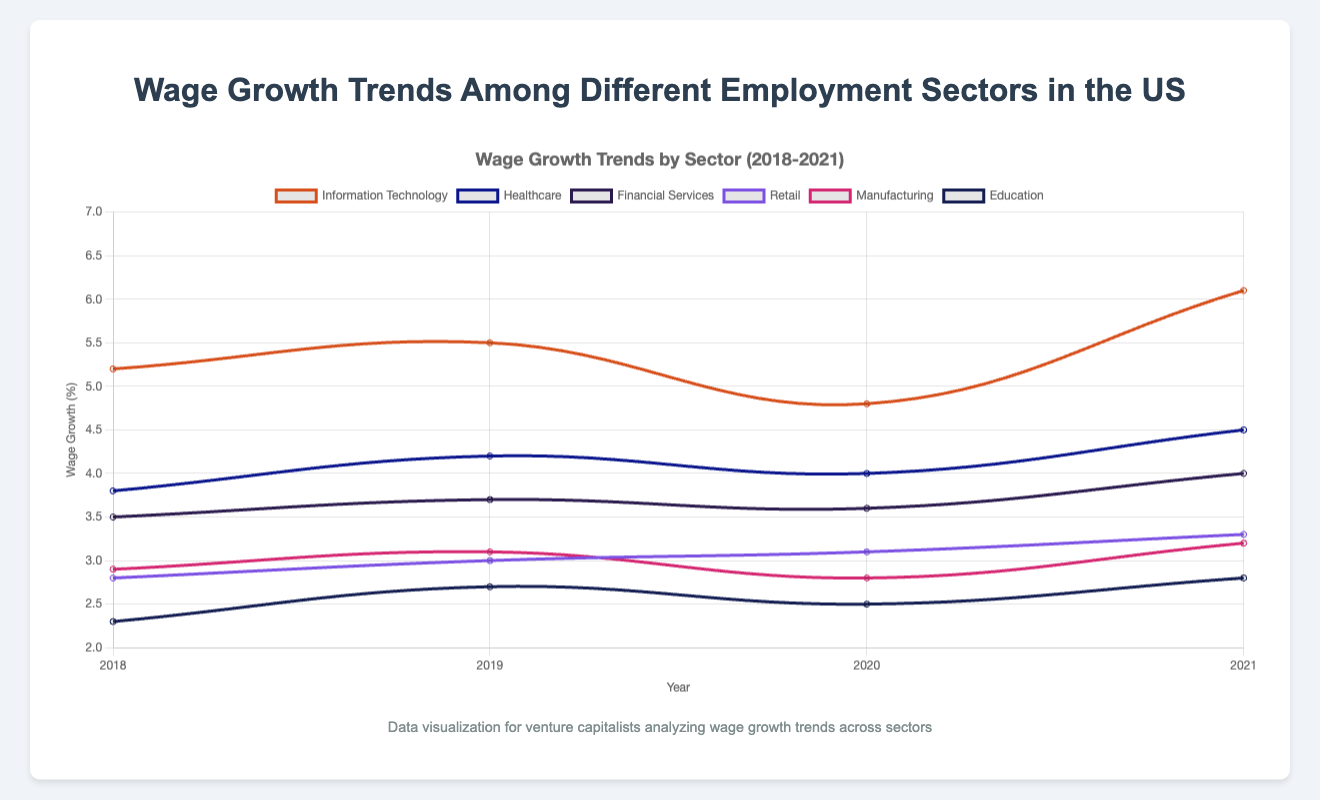Which sector had the highest wage growth in 2021? Look for the highest point in the 2021 data. Information Technology shows the highest value at 6.1%.
Answer: Information Technology How did the wage growth in the Healthcare sector trend from 2018 to 2021? Observe the Healthcare sector trend line. It starts at 3.8% in 2018, rises to 4.2% in 2019, dips slightly to 4.0% in 2020, and rises again to 4.5% in 2021.
Answer: Generally increasing Compare the wage growth trends between Information Technology and Retail sectors from 2018 to 2021. Look at the changes in the lines representing these sectors. Information Technology consistently possesses higher values and displays larger fluctuations, especially peaking in 2021 at 6.1%. Retail shows a slower, steadier increase from 2.8% in 2018 to 3.3% in 2021.
Answer: Information Technology increased faster and has higher growth values What is the average wage growth in the Financial Services sector from 2018 to 2021? Sum the wage growth percentages for each year (3.5 + 3.7 + 3.6 + 4.0 = 14.8) and divide by the number of years (14.8 / 4).
Answer: 3.7% Which sector had the lowest wage growth in 2018? Identify the lowest point in the 2018 data. Education sector had the lowest wage growth at 2.3%.
Answer: Education What is the median wage growth value across all sectors for the year 2019? List all the 2019 wage growth values: 5.5, 4.2, 3.7, 3.0, 3.1, and 2.7. Order them: 2.7, 3.0, 3.1, 3.7, 4.2, 5.5. Since there are 6 values, the median is the average of the 3rd and 4th values (3.1 + 3.7) / 2.
Answer: 3.4% In what year did the Manufacturing sector experience the lowest wage growth, and what was the value? Find the lowest point on the Manufacturing sector's line. The lowest wage growth was 2.8% in 2020.
Answer: 2020, 2.8% From 2018 to 2021, which sector shows the most consistent wage growth and what is the range of growth values within that sector? Consistency implies similar values over years. Financial Services ranges from 3.5% to 4.0%, with minimal variation compared to other sectors.
Answer: Financial Services, range 0.5% Compare the overall trend between Financial Services and Manufacturing sectors. Which one had more consistent growth? Examine both trends. Financial Services shows slight increases each year, whereas Manufacturing has a noticeable dip in 2020. Financial Services is more consistent.
Answer: Financial Services 